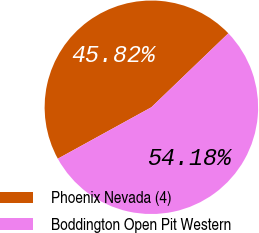Convert chart to OTSL. <chart><loc_0><loc_0><loc_500><loc_500><pie_chart><fcel>Phoenix Nevada (4)<fcel>Boddington Open Pit Western<nl><fcel>45.82%<fcel>54.18%<nl></chart> 